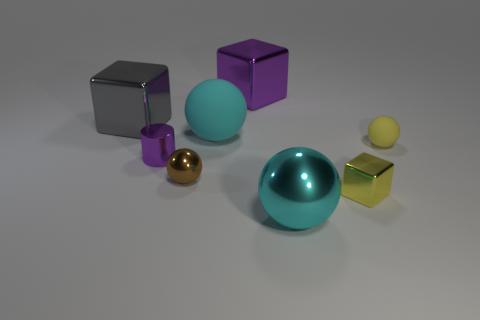Subtract all large shiny blocks. How many blocks are left? 1 Add 1 large purple metallic things. How many objects exist? 9 Subtract all blue balls. Subtract all red cylinders. How many balls are left? 4 Subtract all cylinders. How many objects are left? 7 Subtract all small metallic objects. Subtract all gray shiny things. How many objects are left? 4 Add 8 tiny shiny balls. How many tiny shiny balls are left? 9 Add 1 cylinders. How many cylinders exist? 2 Subtract 2 cyan balls. How many objects are left? 6 